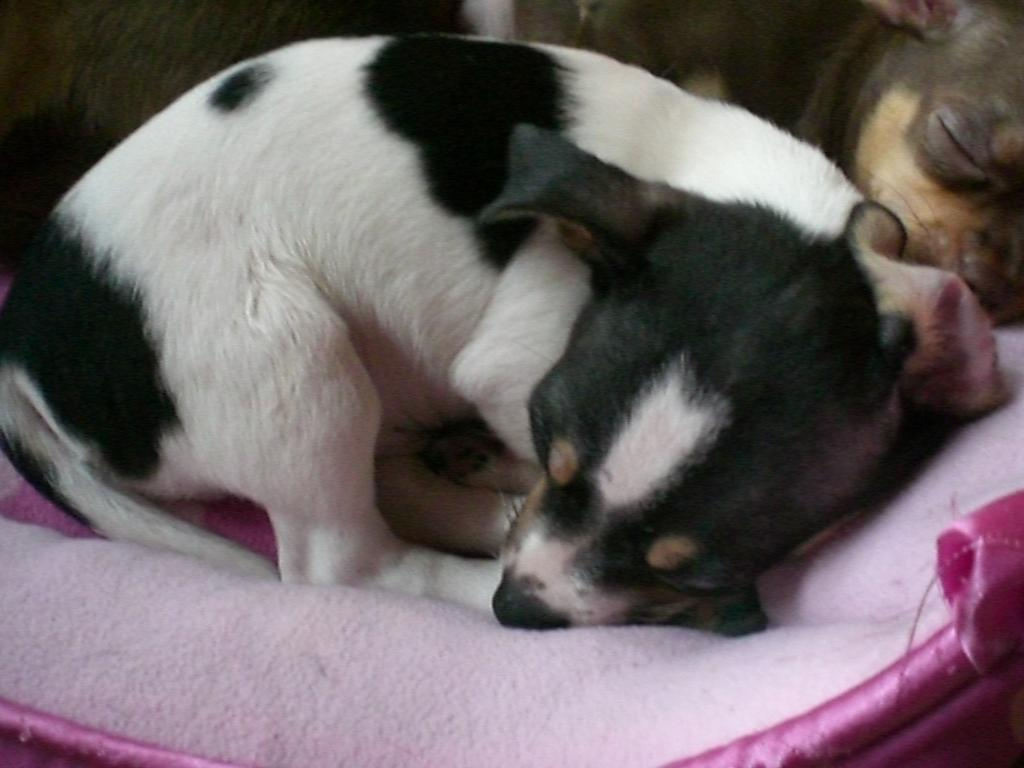How many dogs are present in the image? There are two dogs in the image. What are the dogs doing in the image? The dogs are sleeping on a bed sheet. Can you describe the appearance of the dogs? One dog is black and white in color, while the other dog is brown in color. How many clover leaves can be seen on the dogs' paws in the image? There are no clover leaves visible on the dogs' paws in the image. How many toes does each dog have on their front paws in the image? The image does not show the dogs' toes, so it is not possible to determine the number of toes on their front paws. 